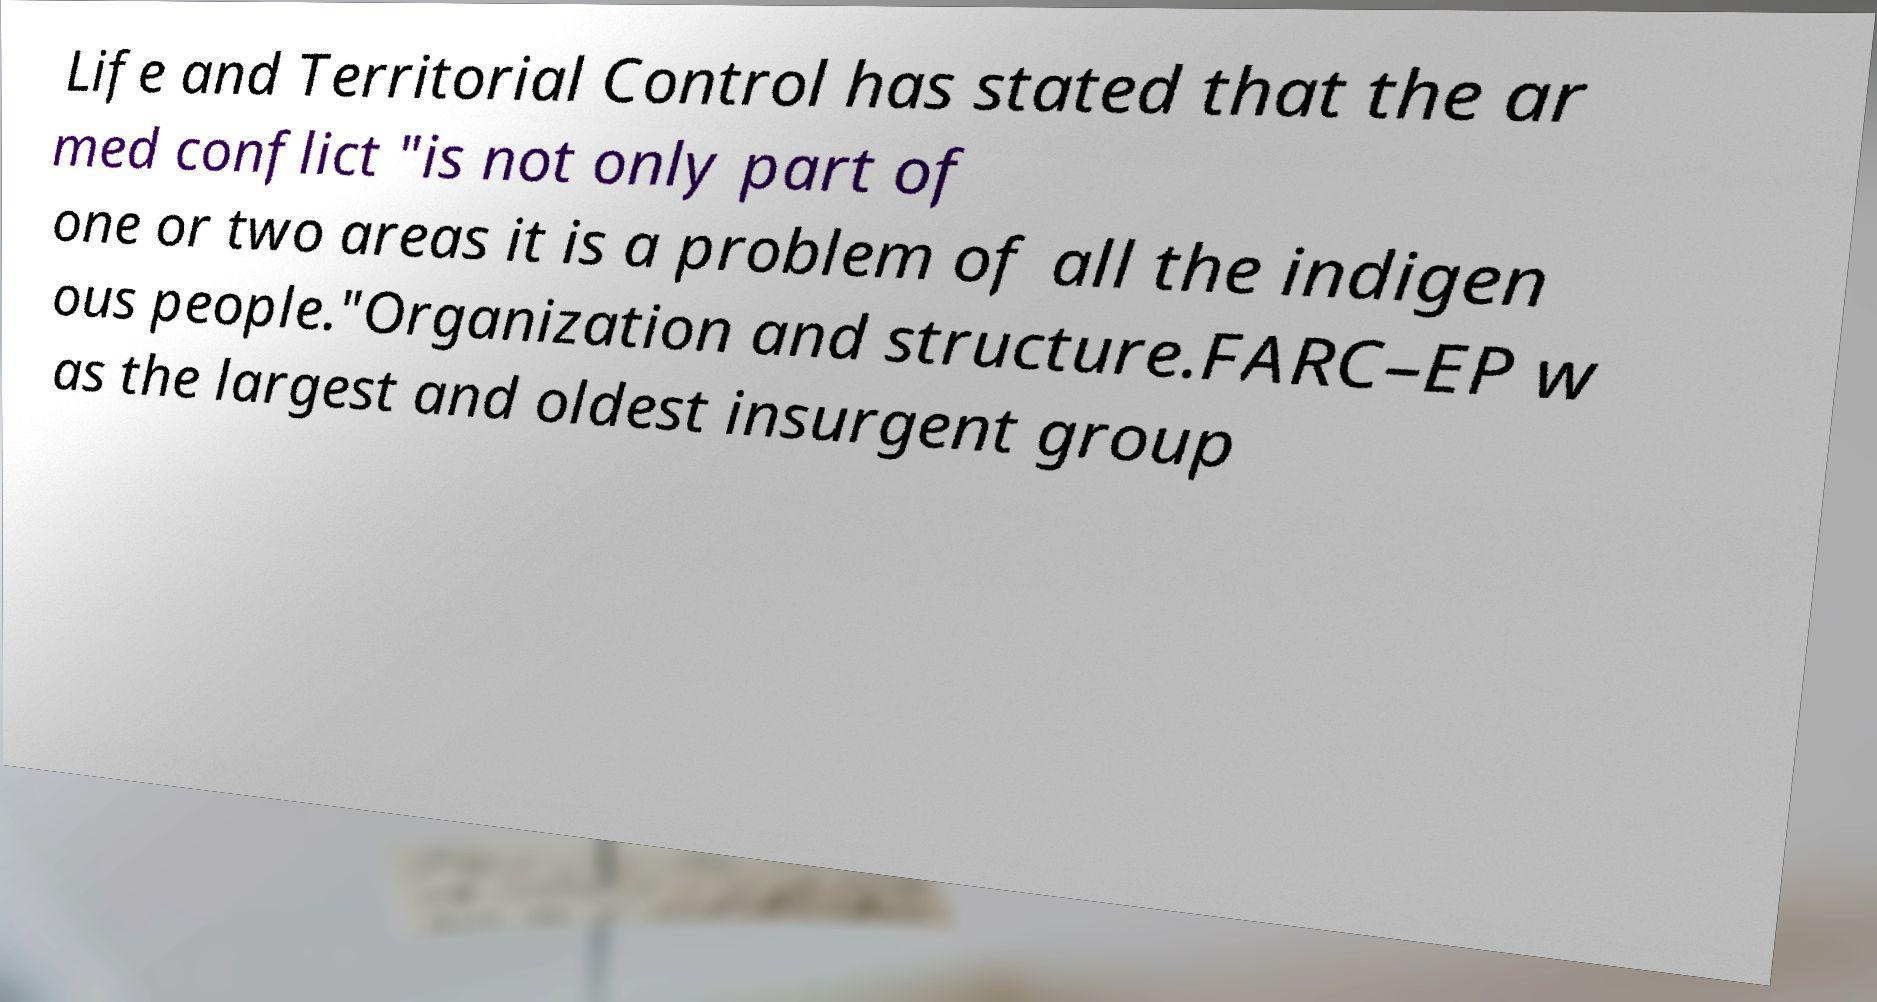Could you extract and type out the text from this image? Life and Territorial Control has stated that the ar med conflict "is not only part of one or two areas it is a problem of all the indigen ous people."Organization and structure.FARC–EP w as the largest and oldest insurgent group 